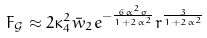<formula> <loc_0><loc_0><loc_500><loc_500>F _ { \mathcal { G } } \approx 2 \kappa _ { 4 } ^ { 2 } \bar { w } _ { 2 } e ^ { - \frac { 6 \alpha ^ { 2 } \sigma } { 1 + 2 \alpha ^ { 2 } } } r ^ { \frac { 3 } { 1 + 2 \alpha ^ { 2 } } }</formula> 